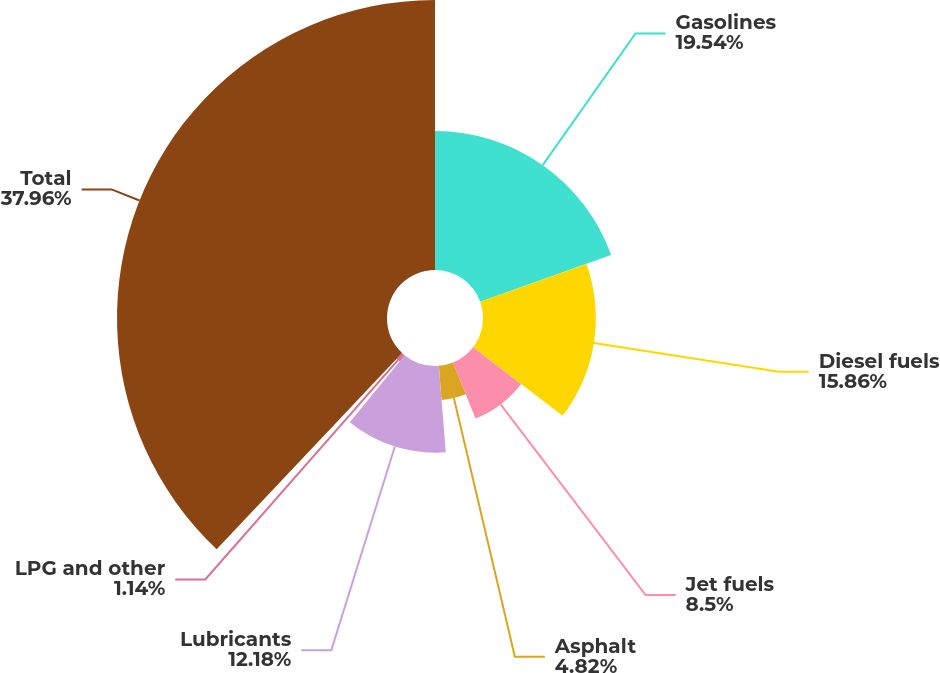Convert chart to OTSL. <chart><loc_0><loc_0><loc_500><loc_500><pie_chart><fcel>Gasolines<fcel>Diesel fuels<fcel>Jet fuels<fcel>Asphalt<fcel>Lubricants<fcel>LPG and other<fcel>Total<nl><fcel>19.54%<fcel>15.86%<fcel>8.5%<fcel>4.82%<fcel>12.18%<fcel>1.14%<fcel>37.95%<nl></chart> 